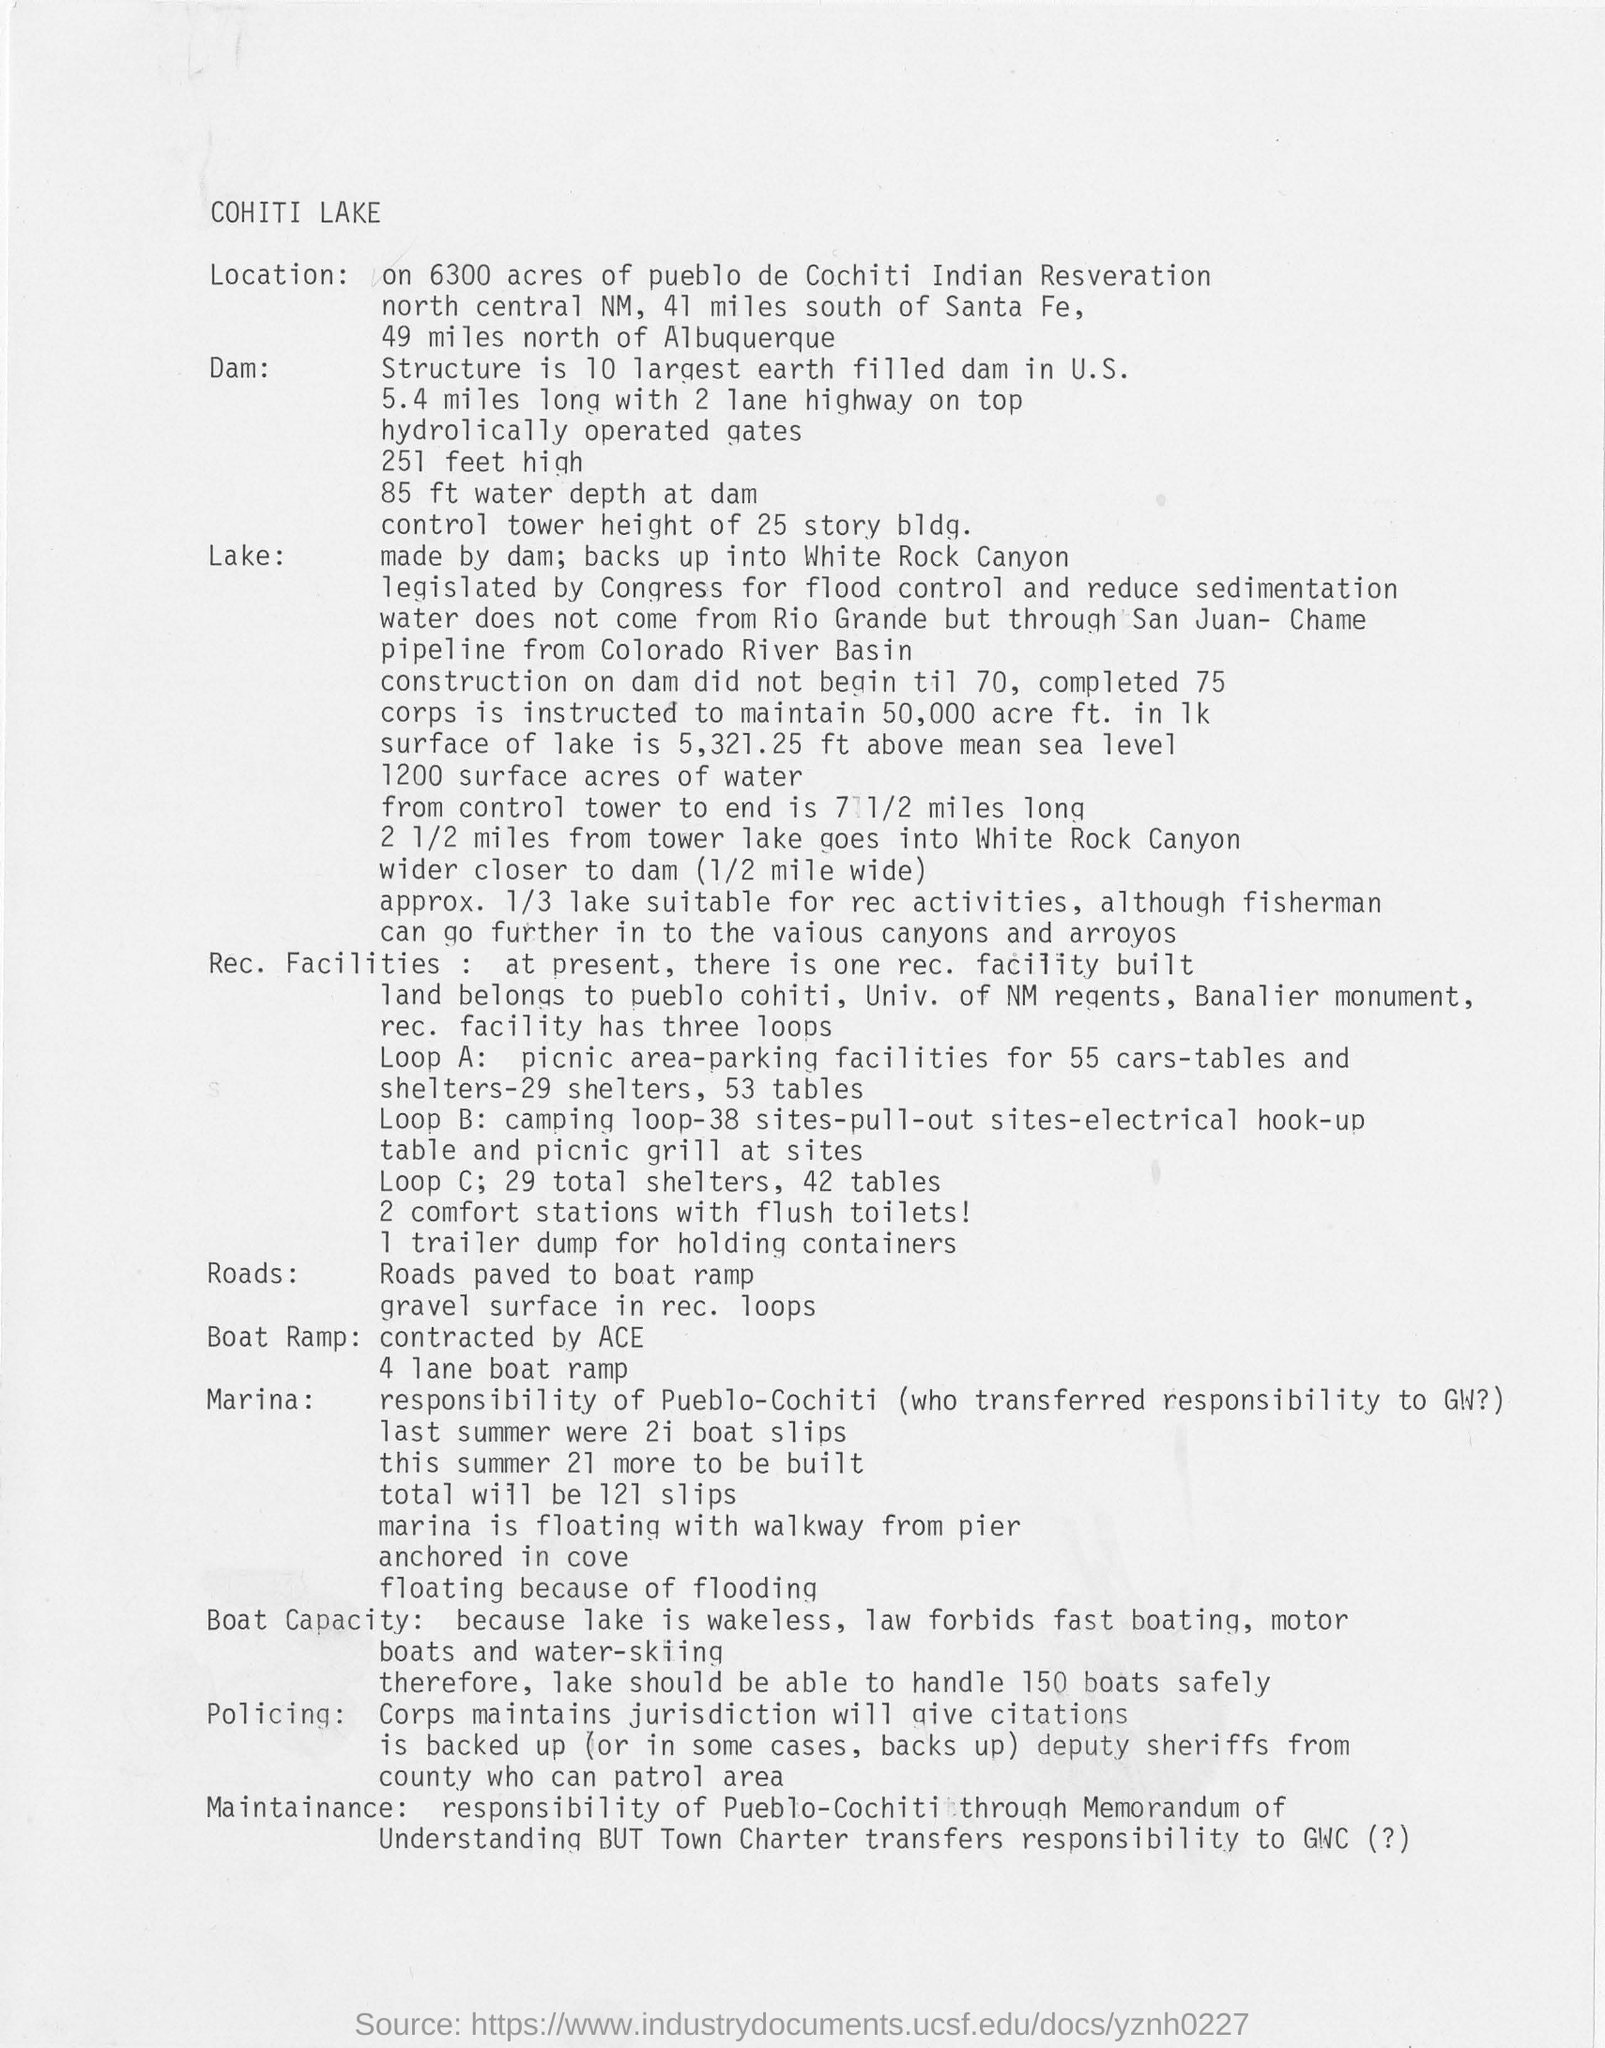What is the name of the lake ?
Your answer should be compact. Cohiti lake. Which company contracted the boat ramp
Your answer should be compact. ACE. How many boats the lake should be able to handle safely?
Your answer should be compact. 150. What is the distance of the lake from albuquerque?
Your response must be concise. 49 miles north of Albuquerque. 